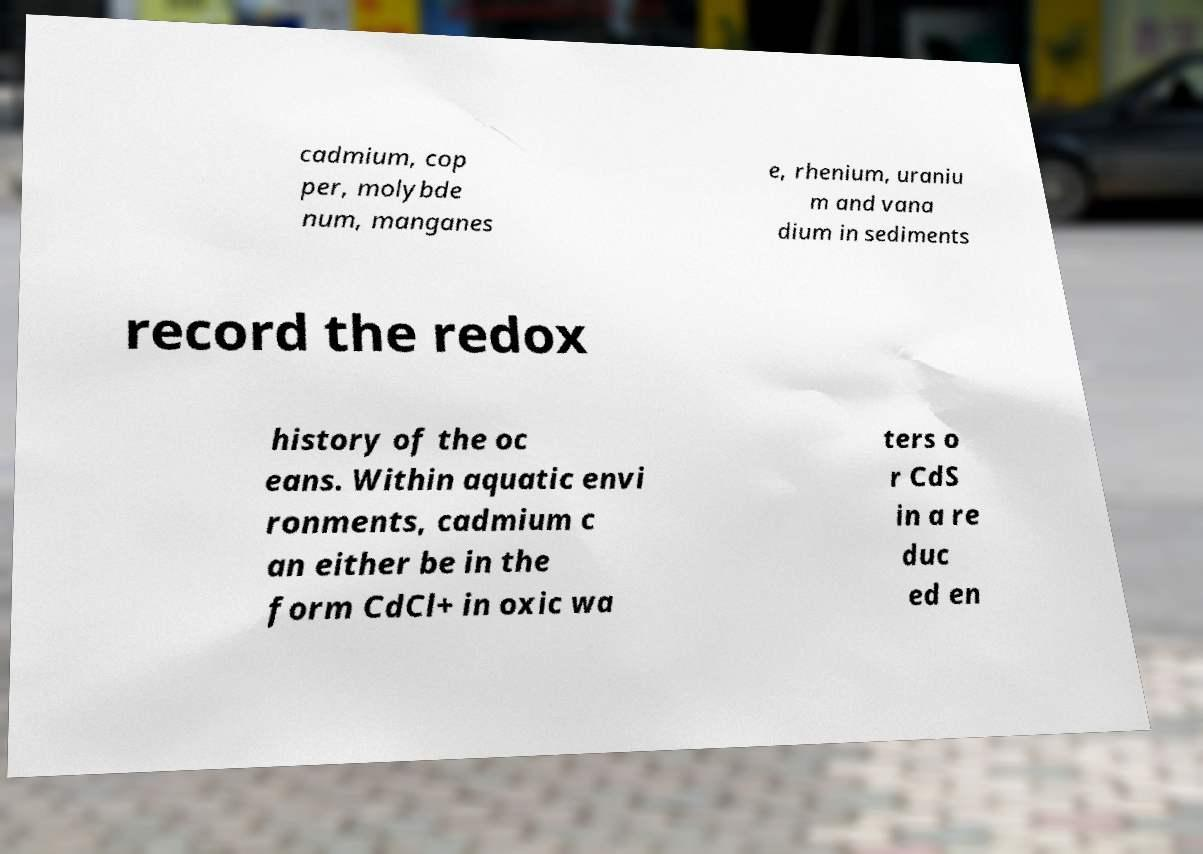Can you accurately transcribe the text from the provided image for me? cadmium, cop per, molybde num, manganes e, rhenium, uraniu m and vana dium in sediments record the redox history of the oc eans. Within aquatic envi ronments, cadmium c an either be in the form CdCl+ in oxic wa ters o r CdS in a re duc ed en 